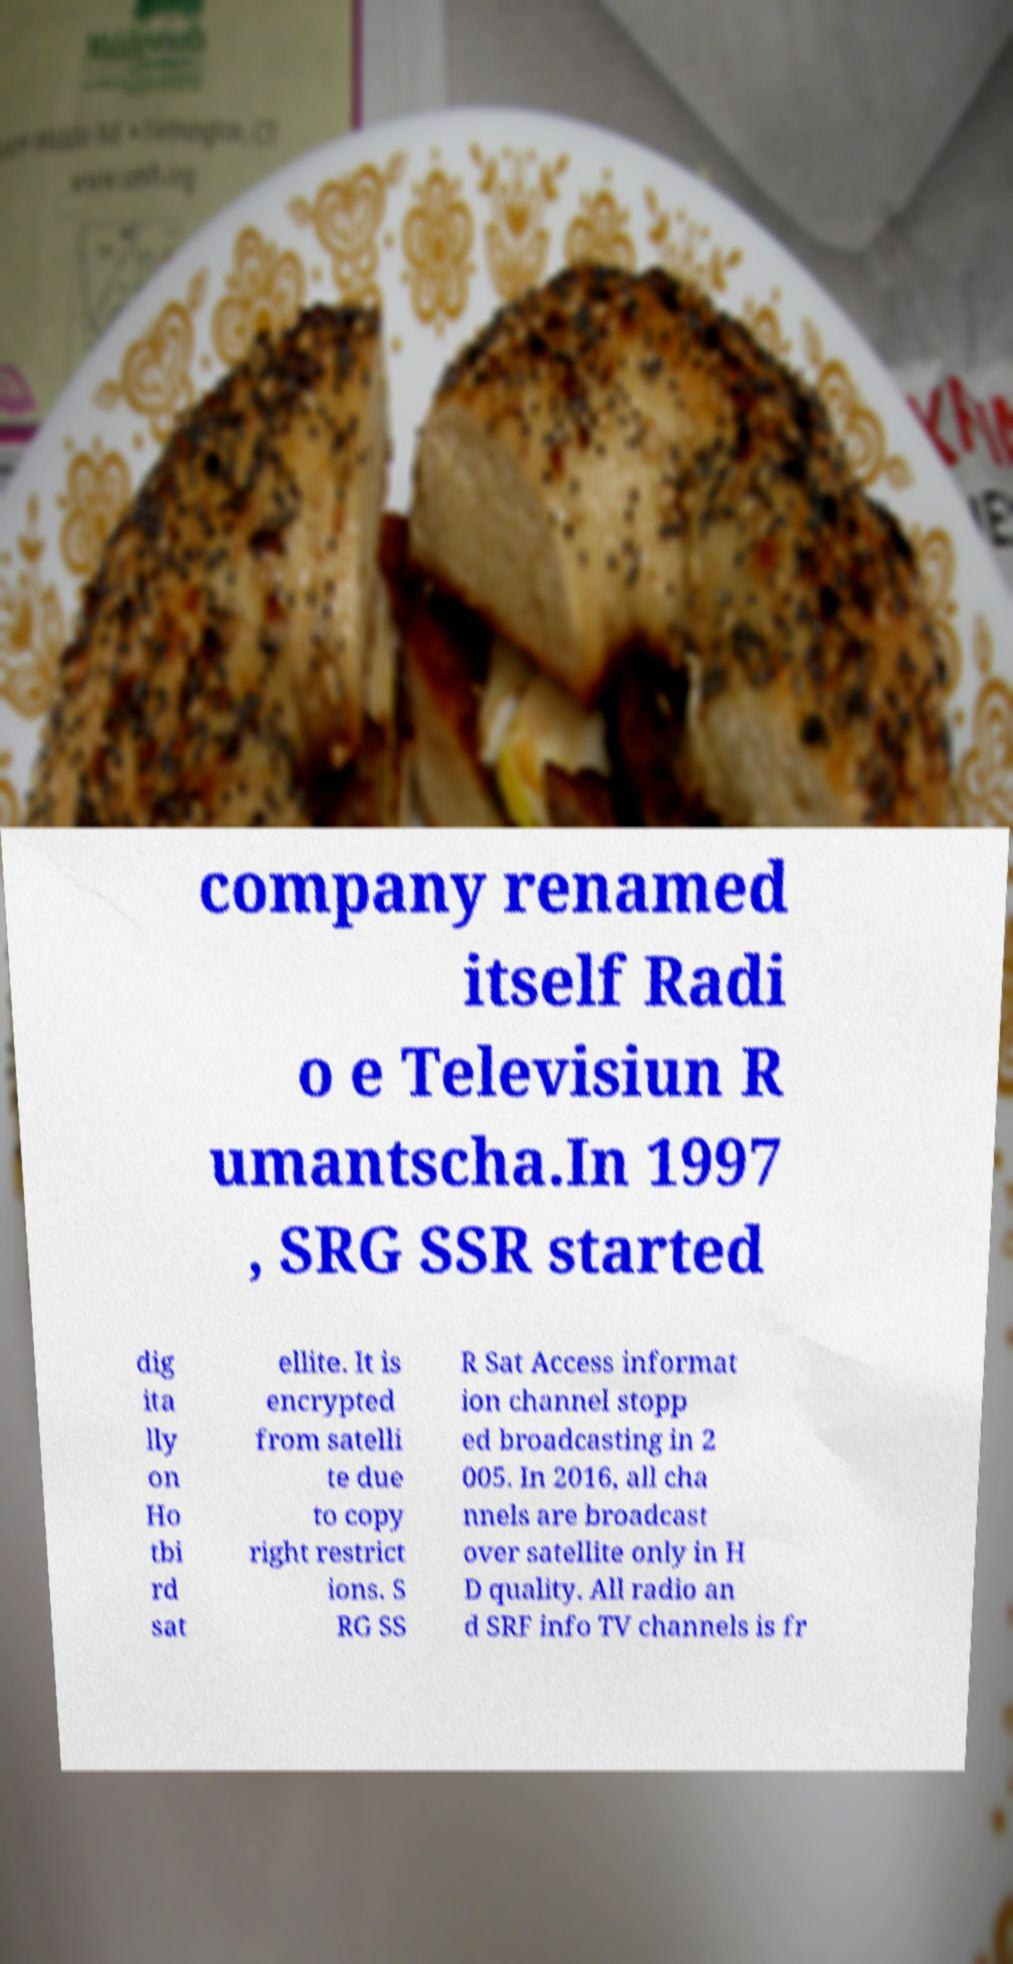Please identify and transcribe the text found in this image. company renamed itself Radi o e Televisiun R umantscha.In 1997 , SRG SSR started dig ita lly on Ho tbi rd sat ellite. It is encrypted from satelli te due to copy right restrict ions. S RG SS R Sat Access informat ion channel stopp ed broadcasting in 2 005. In 2016, all cha nnels are broadcast over satellite only in H D quality. All radio an d SRF info TV channels is fr 